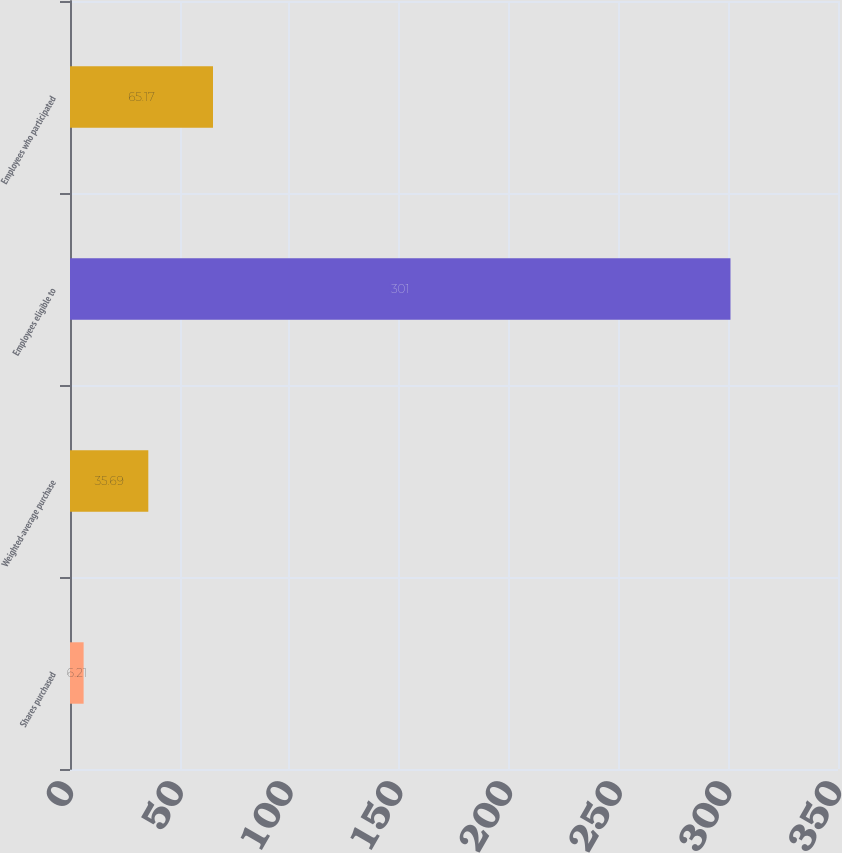Convert chart to OTSL. <chart><loc_0><loc_0><loc_500><loc_500><bar_chart><fcel>Shares purchased<fcel>Weighted-average purchase<fcel>Employees eligible to<fcel>Employees who participated<nl><fcel>6.21<fcel>35.69<fcel>301<fcel>65.17<nl></chart> 